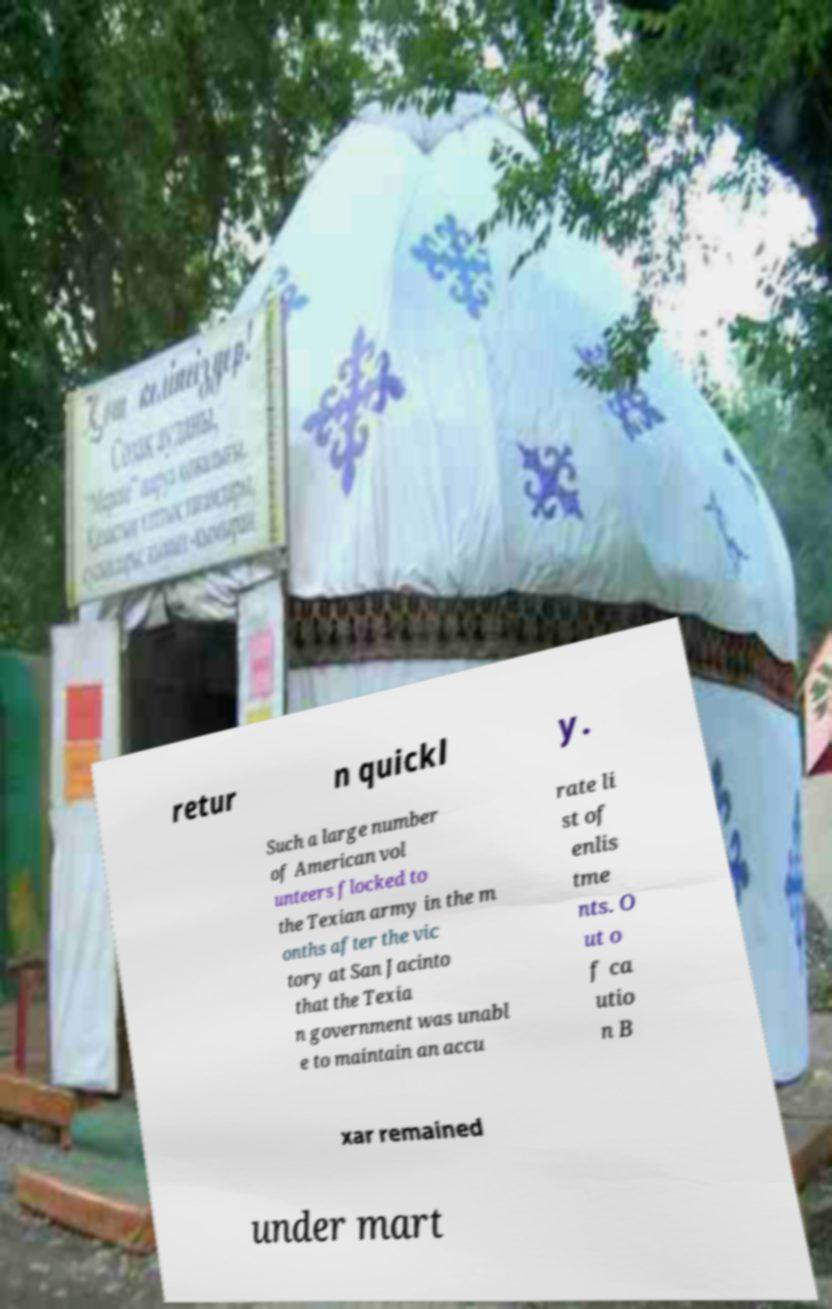Could you assist in decoding the text presented in this image and type it out clearly? retur n quickl y. Such a large number of American vol unteers flocked to the Texian army in the m onths after the vic tory at San Jacinto that the Texia n government was unabl e to maintain an accu rate li st of enlis tme nts. O ut o f ca utio n B xar remained under mart 